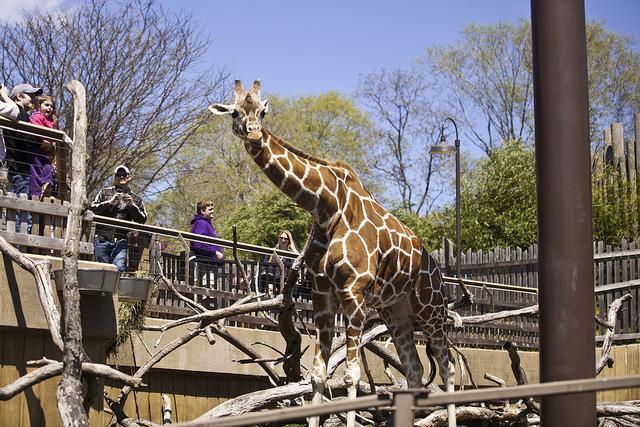How many people are there?
Give a very brief answer. 6. How many people can be seen?
Give a very brief answer. 2. How many red cars are driving on the road?
Give a very brief answer. 0. 